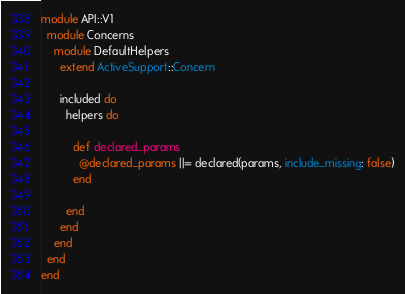<code> <loc_0><loc_0><loc_500><loc_500><_Ruby_>module API::V1
  module Concerns
    module DefaultHelpers
      extend ActiveSupport::Concern
     
      included do
        helpers do

          def declared_params
            @declared_params ||= declared(params, include_missing: false)
          end

        end
      end
    end
  end
end
</code> 